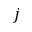<formula> <loc_0><loc_0><loc_500><loc_500>j</formula> 